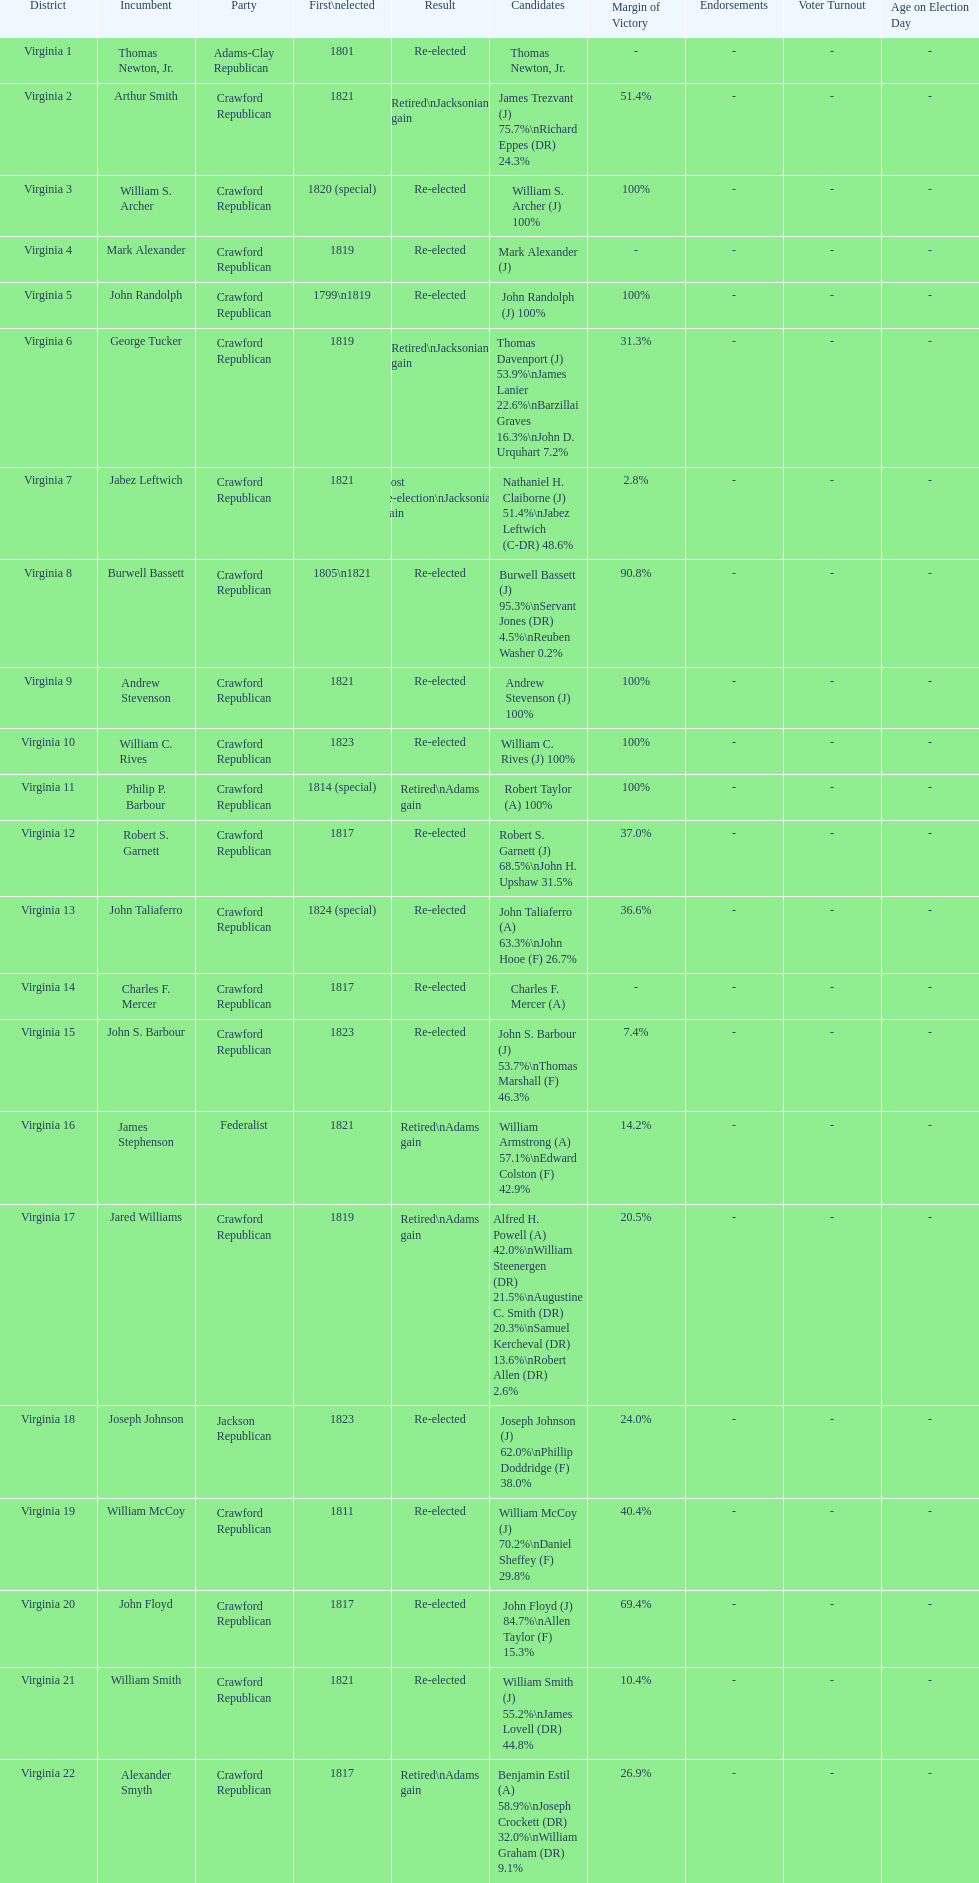What are the number of times re-elected is listed as the result? 15. 